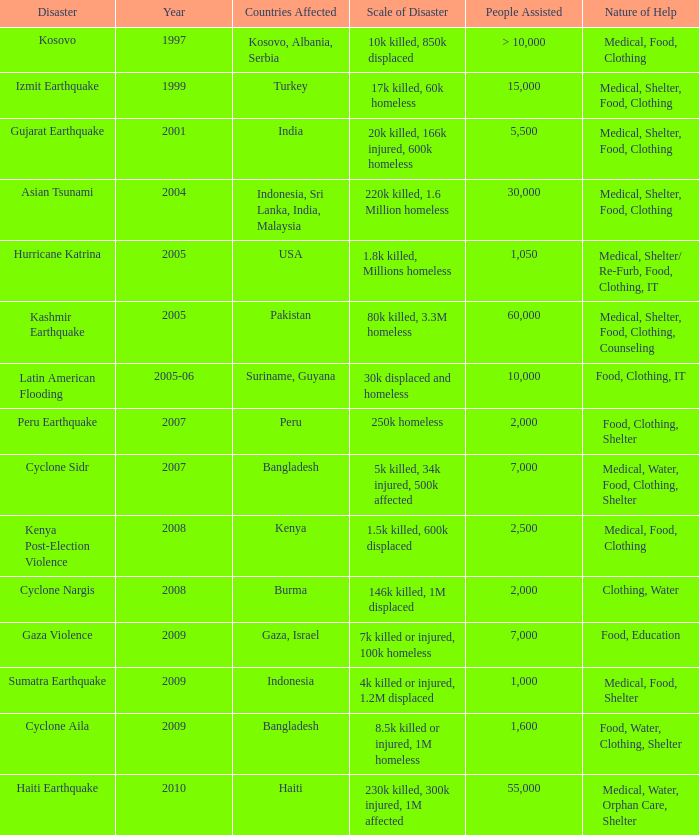What is the scale of disaster for the USA? 1.8k killed, Millions homeless. 